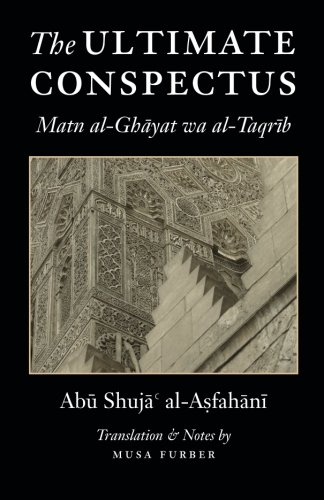What language is this book originally written in, and who has translated it? Originally written in Arabic, 'The Ultimate Conspectus' has been translated into English by Musa Furber, who has also provided notes to aid in understanding the text's context and applications. 